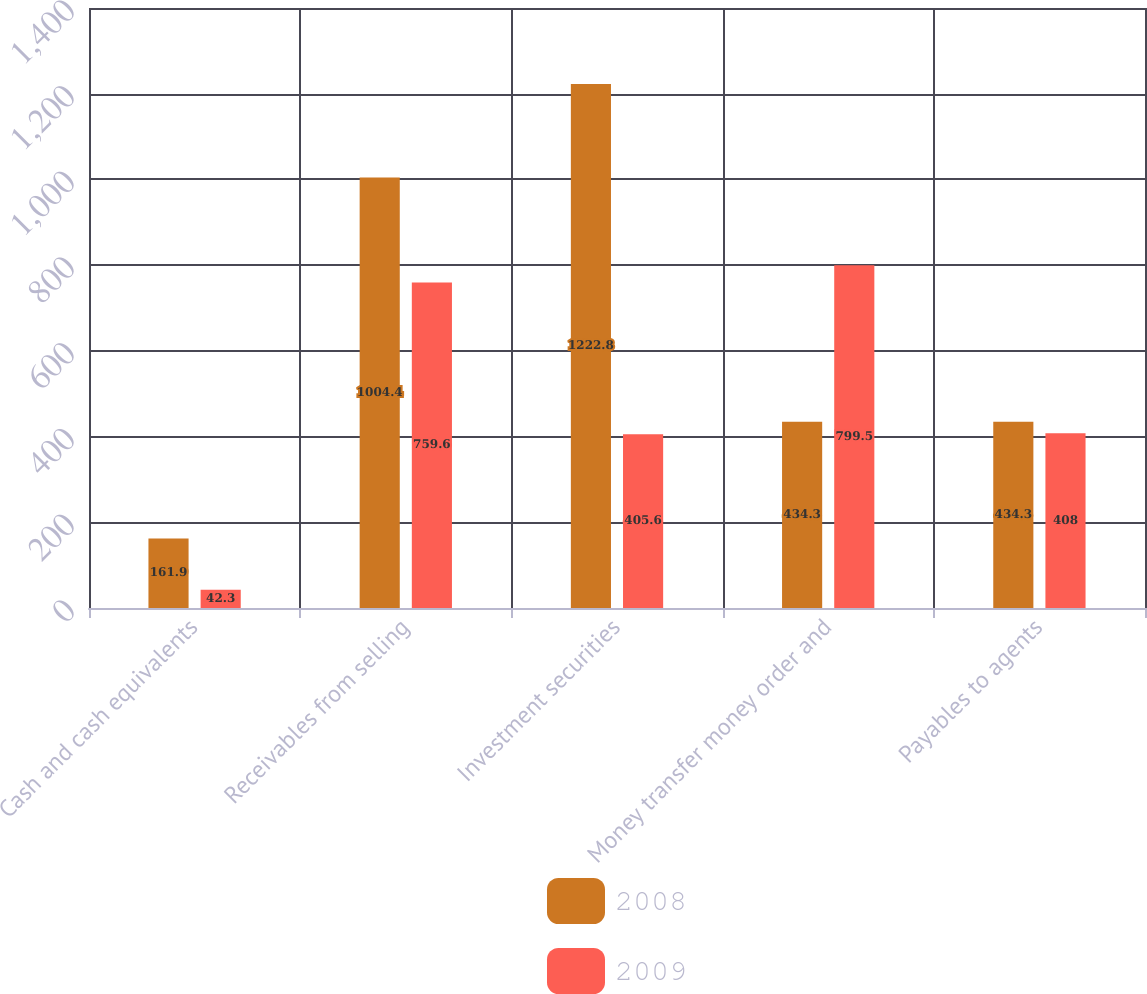Convert chart. <chart><loc_0><loc_0><loc_500><loc_500><stacked_bar_chart><ecel><fcel>Cash and cash equivalents<fcel>Receivables from selling<fcel>Investment securities<fcel>Money transfer money order and<fcel>Payables to agents<nl><fcel>2008<fcel>161.9<fcel>1004.4<fcel>1222.8<fcel>434.3<fcel>434.3<nl><fcel>2009<fcel>42.3<fcel>759.6<fcel>405.6<fcel>799.5<fcel>408<nl></chart> 